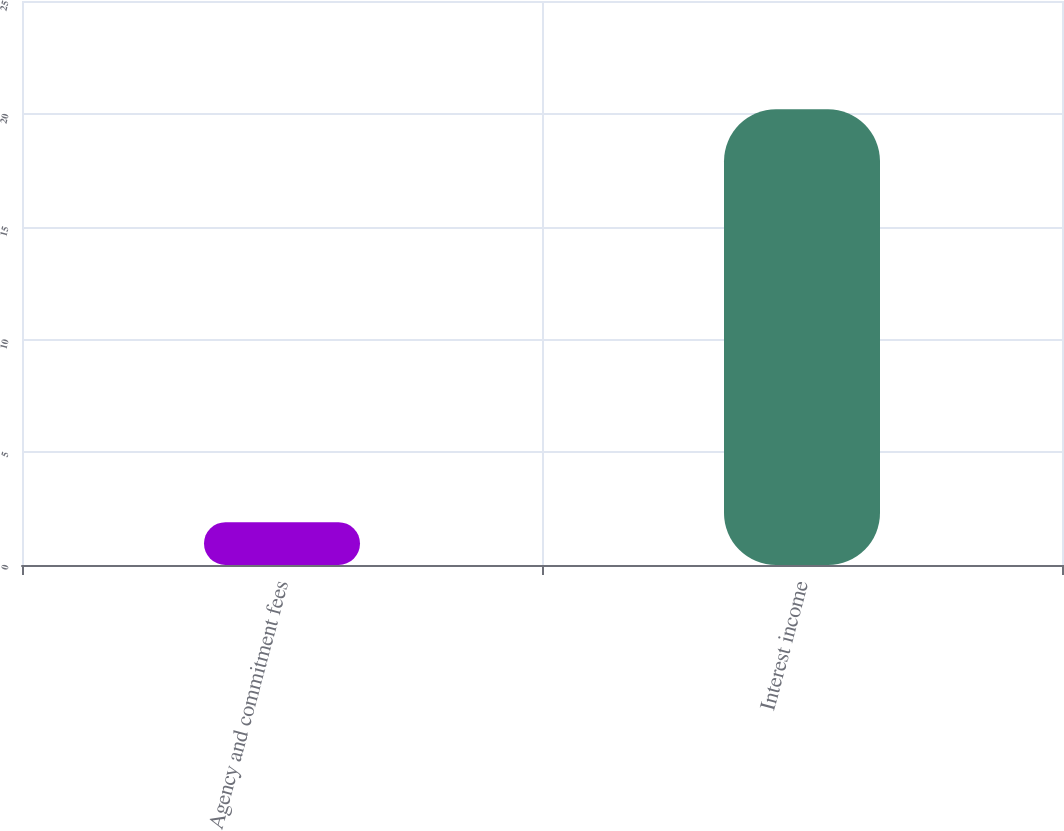<chart> <loc_0><loc_0><loc_500><loc_500><bar_chart><fcel>Agency and commitment fees<fcel>Interest income<nl><fcel>1.9<fcel>20.2<nl></chart> 